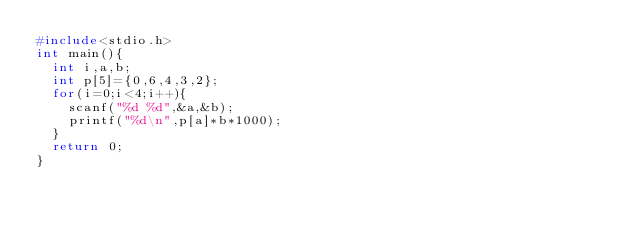Convert code to text. <code><loc_0><loc_0><loc_500><loc_500><_C_>#include<stdio.h>
int main(){
  int i,a,b;
  int p[5]={0,6,4,3,2};
  for(i=0;i<4;i++){
    scanf("%d %d",&a,&b);
    printf("%d\n",p[a]*b*1000);
  }
  return 0;
}</code> 